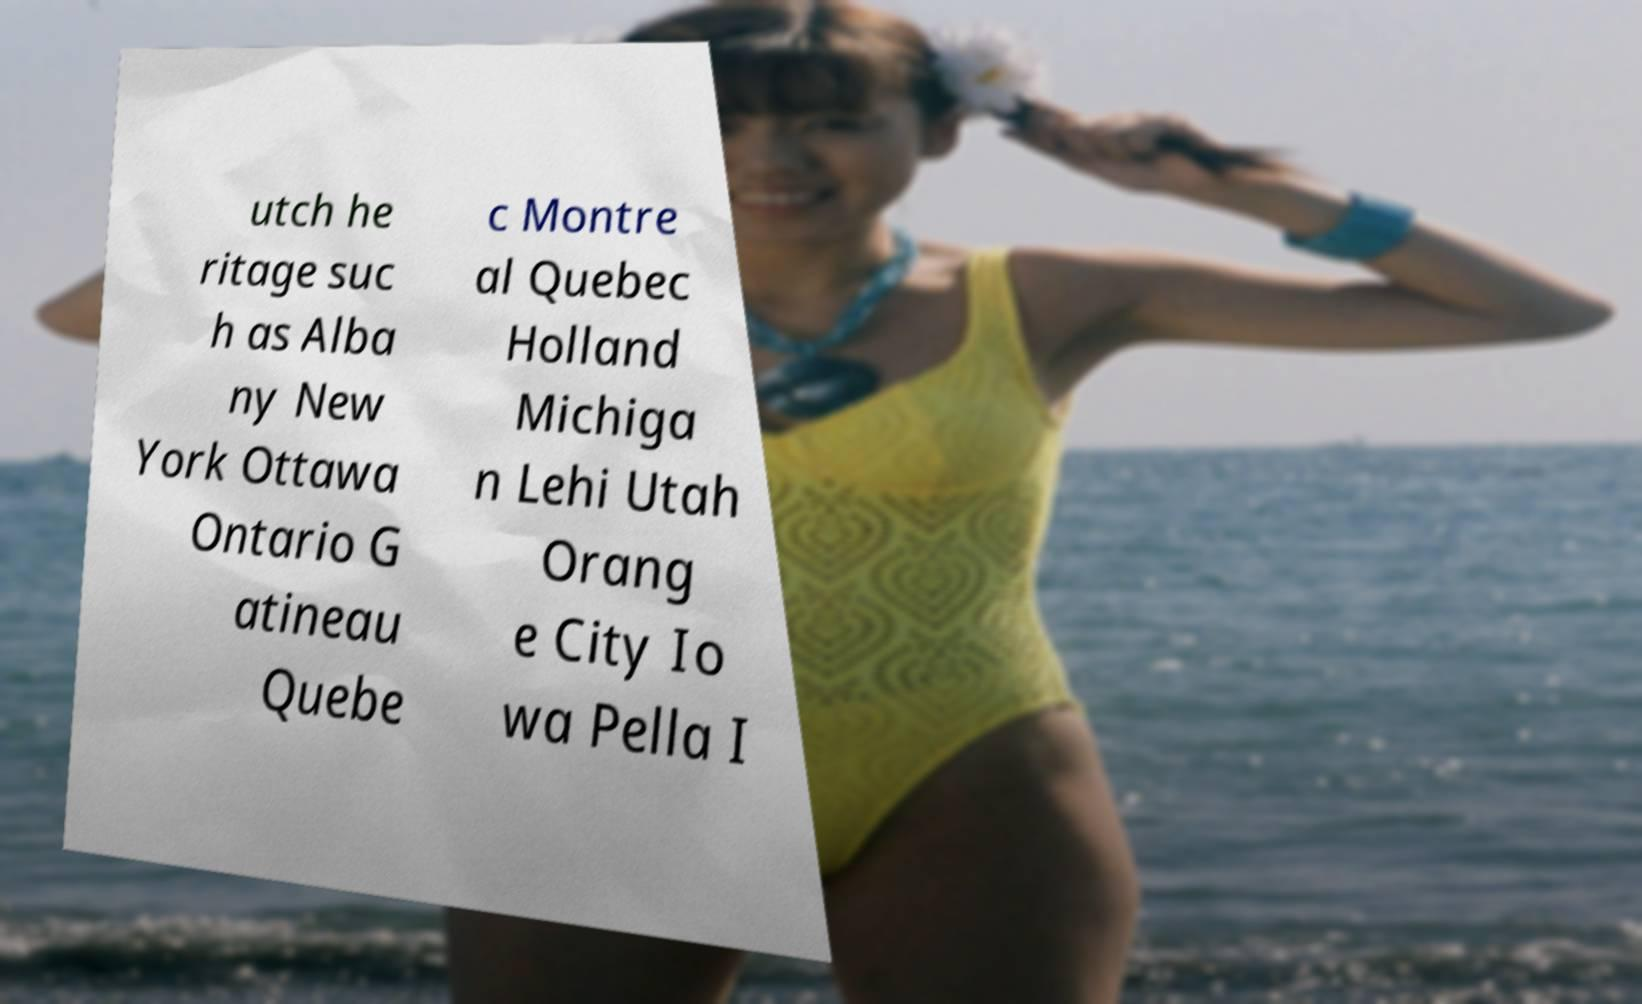Can you accurately transcribe the text from the provided image for me? utch he ritage suc h as Alba ny New York Ottawa Ontario G atineau Quebe c Montre al Quebec Holland Michiga n Lehi Utah Orang e City Io wa Pella I 